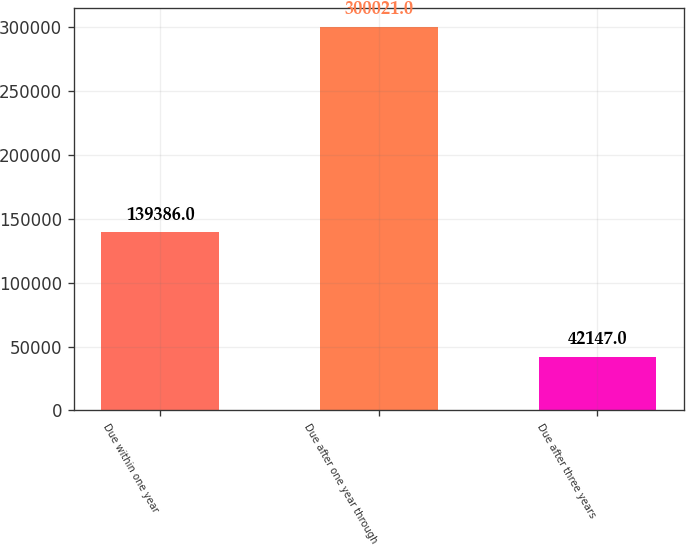Convert chart. <chart><loc_0><loc_0><loc_500><loc_500><bar_chart><fcel>Due within one year<fcel>Due after one year through<fcel>Due after three years<nl><fcel>139386<fcel>300021<fcel>42147<nl></chart> 